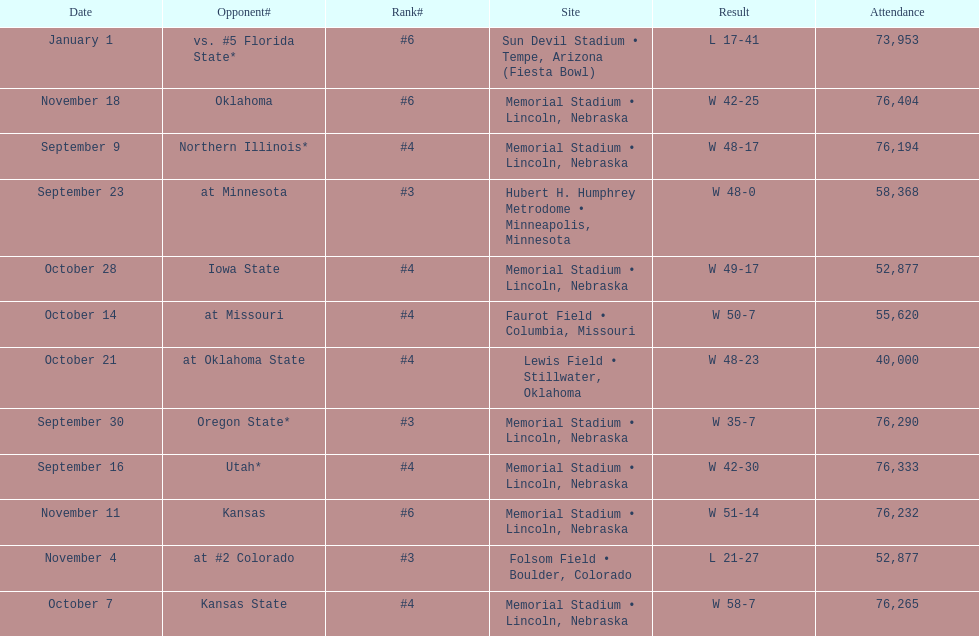What site at most is taken place? Memorial Stadium • Lincoln, Nebraska. 